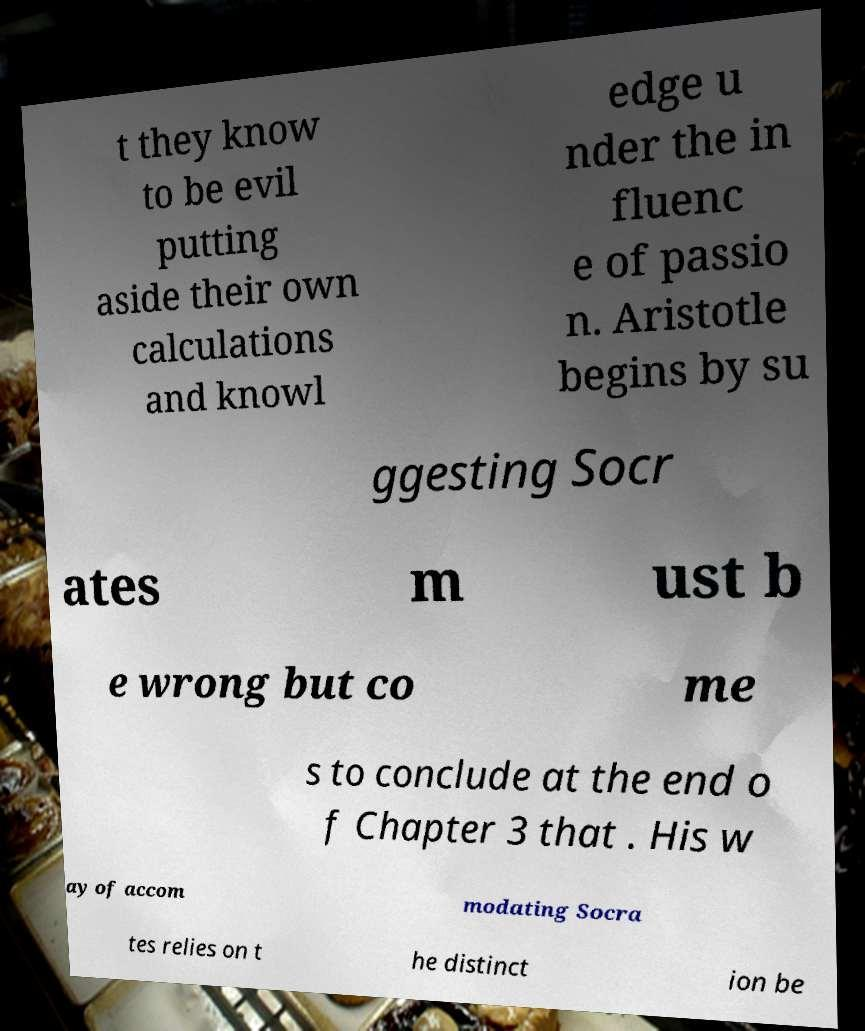I need the written content from this picture converted into text. Can you do that? t they know to be evil putting aside their own calculations and knowl edge u nder the in fluenc e of passio n. Aristotle begins by su ggesting Socr ates m ust b e wrong but co me s to conclude at the end o f Chapter 3 that . His w ay of accom modating Socra tes relies on t he distinct ion be 